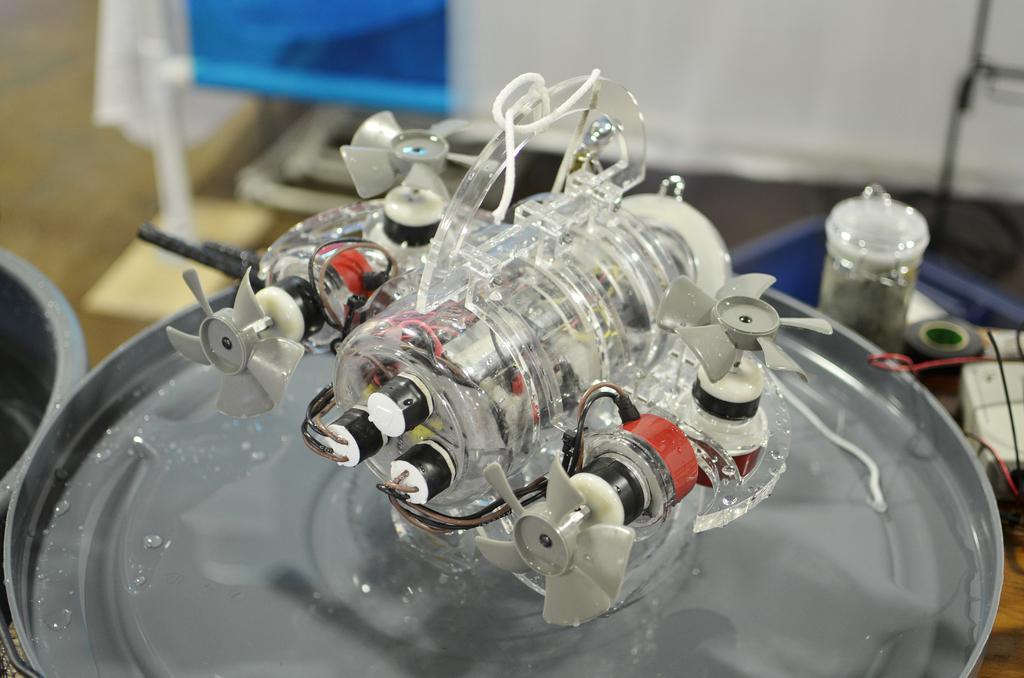Could you give a brief overview of what you see in this image? In this image we can see there are some objects placed on the metal plate. 